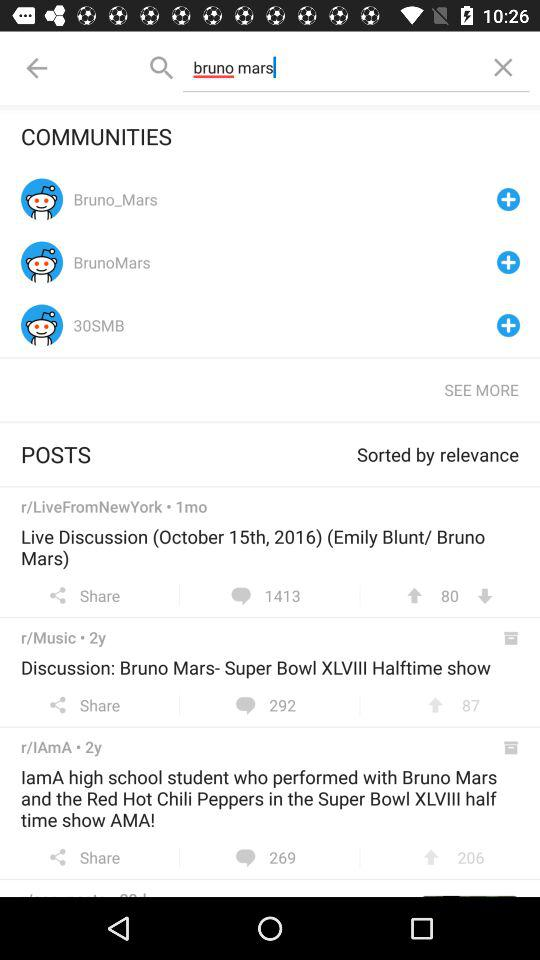How many comments are there on "Live Discussion"? There are 1413 comments. 